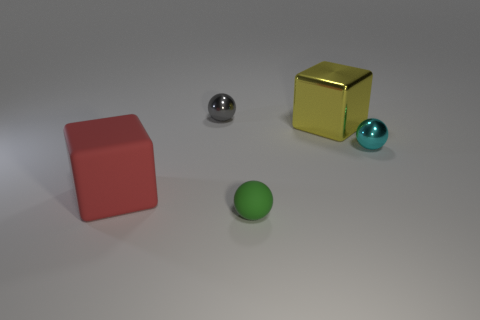Can you describe the lighting condition in the scene and how it might influence the perception of the objects? The lighting in the scene appears to come from above, casting soft shadows beneath each object. The gentle illumination accentuates the three-dimensionality of the objects and their positioning in space. It affects our perception by drawing attention to the contours, while the shadows give us clues about the shapes and volumes present. 